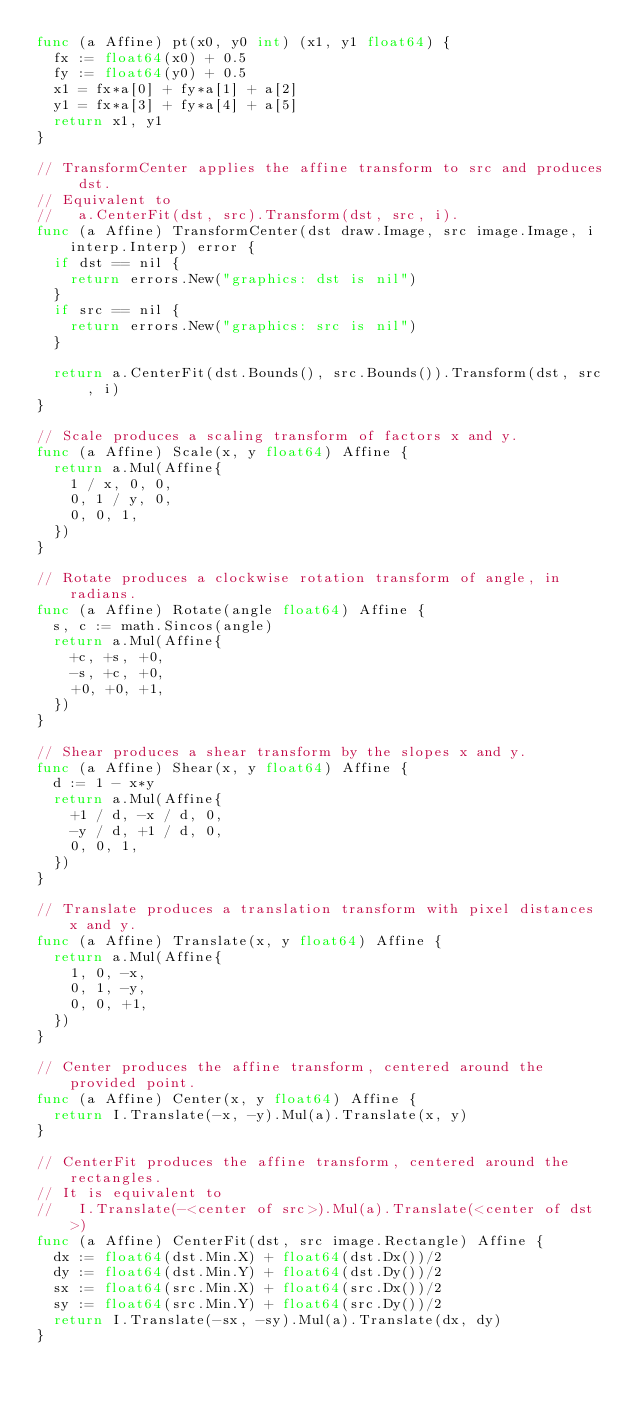<code> <loc_0><loc_0><loc_500><loc_500><_Go_>func (a Affine) pt(x0, y0 int) (x1, y1 float64) {
	fx := float64(x0) + 0.5
	fy := float64(y0) + 0.5
	x1 = fx*a[0] + fy*a[1] + a[2]
	y1 = fx*a[3] + fy*a[4] + a[5]
	return x1, y1
}

// TransformCenter applies the affine transform to src and produces dst.
// Equivalent to
//   a.CenterFit(dst, src).Transform(dst, src, i).
func (a Affine) TransformCenter(dst draw.Image, src image.Image, i interp.Interp) error {
	if dst == nil {
		return errors.New("graphics: dst is nil")
	}
	if src == nil {
		return errors.New("graphics: src is nil")
	}

	return a.CenterFit(dst.Bounds(), src.Bounds()).Transform(dst, src, i)
}

// Scale produces a scaling transform of factors x and y.
func (a Affine) Scale(x, y float64) Affine {
	return a.Mul(Affine{
		1 / x, 0, 0,
		0, 1 / y, 0,
		0, 0, 1,
	})
}

// Rotate produces a clockwise rotation transform of angle, in radians.
func (a Affine) Rotate(angle float64) Affine {
	s, c := math.Sincos(angle)
	return a.Mul(Affine{
		+c, +s, +0,
		-s, +c, +0,
		+0, +0, +1,
	})
}

// Shear produces a shear transform by the slopes x and y.
func (a Affine) Shear(x, y float64) Affine {
	d := 1 - x*y
	return a.Mul(Affine{
		+1 / d, -x / d, 0,
		-y / d, +1 / d, 0,
		0, 0, 1,
	})
}

// Translate produces a translation transform with pixel distances x and y.
func (a Affine) Translate(x, y float64) Affine {
	return a.Mul(Affine{
		1, 0, -x,
		0, 1, -y,
		0, 0, +1,
	})
}

// Center produces the affine transform, centered around the provided point.
func (a Affine) Center(x, y float64) Affine {
	return I.Translate(-x, -y).Mul(a).Translate(x, y)
}

// CenterFit produces the affine transform, centered around the rectangles.
// It is equivalent to
//   I.Translate(-<center of src>).Mul(a).Translate(<center of dst>)
func (a Affine) CenterFit(dst, src image.Rectangle) Affine {
	dx := float64(dst.Min.X) + float64(dst.Dx())/2
	dy := float64(dst.Min.Y) + float64(dst.Dy())/2
	sx := float64(src.Min.X) + float64(src.Dx())/2
	sy := float64(src.Min.Y) + float64(src.Dy())/2
	return I.Translate(-sx, -sy).Mul(a).Translate(dx, dy)
}
</code> 